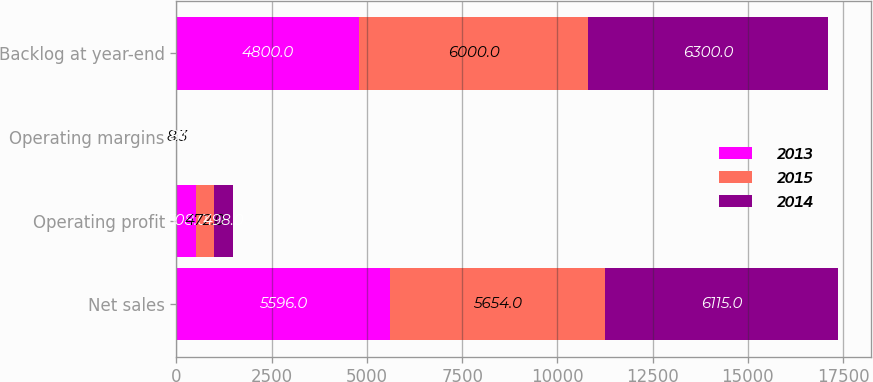Convert chart. <chart><loc_0><loc_0><loc_500><loc_500><stacked_bar_chart><ecel><fcel>Net sales<fcel>Operating profit<fcel>Operating margins<fcel>Backlog at year-end<nl><fcel>2013<fcel>5596<fcel>508<fcel>9.1<fcel>4800<nl><fcel>2015<fcel>5654<fcel>472<fcel>8.3<fcel>6000<nl><fcel>2014<fcel>6115<fcel>498<fcel>8.1<fcel>6300<nl></chart> 